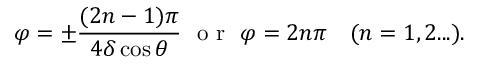Convert formula to latex. <formula><loc_0><loc_0><loc_500><loc_500>\varphi = \pm \frac { ( 2 n - 1 ) \pi } { 4 \delta \cos { \theta } } \ o r \ \varphi = 2 n \pi \quad ( n = 1 , 2 \dots ) .</formula> 